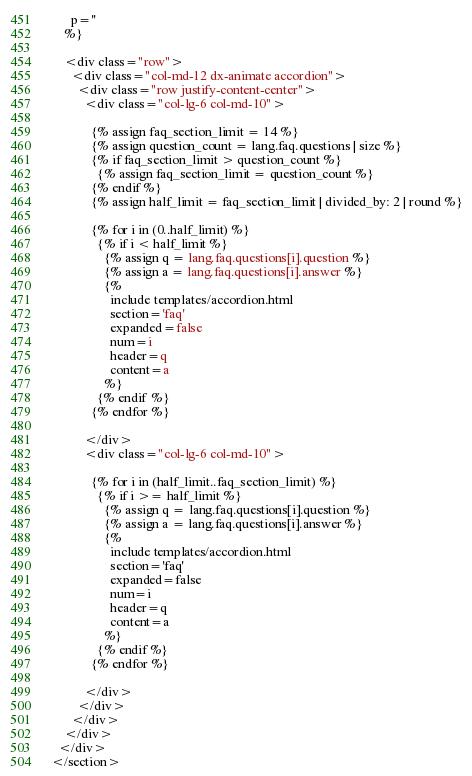<code> <loc_0><loc_0><loc_500><loc_500><_HTML_>      p=''
    %}

    <div class="row">
      <div class="col-md-12 dx-animate accordion">
        <div class="row justify-content-center">
          <div class="col-lg-6 col-md-10">

            {% assign faq_section_limit = 14 %}
            {% assign question_count = lang.faq.questions | size %}
            {% if faq_section_limit > question_count %}
              {% assign faq_section_limit = question_count %}
            {% endif %}
            {% assign half_limit = faq_section_limit | divided_by: 2 | round %}

            {% for i in (0..half_limit) %}
              {% if i < half_limit %}
                {% assign q = lang.faq.questions[i].question %}
                {% assign a = lang.faq.questions[i].answer %}
                {% 
                  include templates/accordion.html
                  section='faq'
                  expanded=false
                  num=i
                  header=q
                  content=a
                %}
              {% endif %}
            {% endfor %}

          </div>
          <div class="col-lg-6 col-md-10">

            {% for i in (half_limit..faq_section_limit) %}
              {% if i >= half_limit %}
                {% assign q = lang.faq.questions[i].question %}
                {% assign a = lang.faq.questions[i].answer %}
                {% 
                  include templates/accordion.html
                  section='faq'
                  expanded=false
                  num=i
                  header=q
                  content=a
                %}
              {% endif %}
            {% endfor %}

          </div>
        </div>
      </div>
    </div>
  </div>
</section></code> 